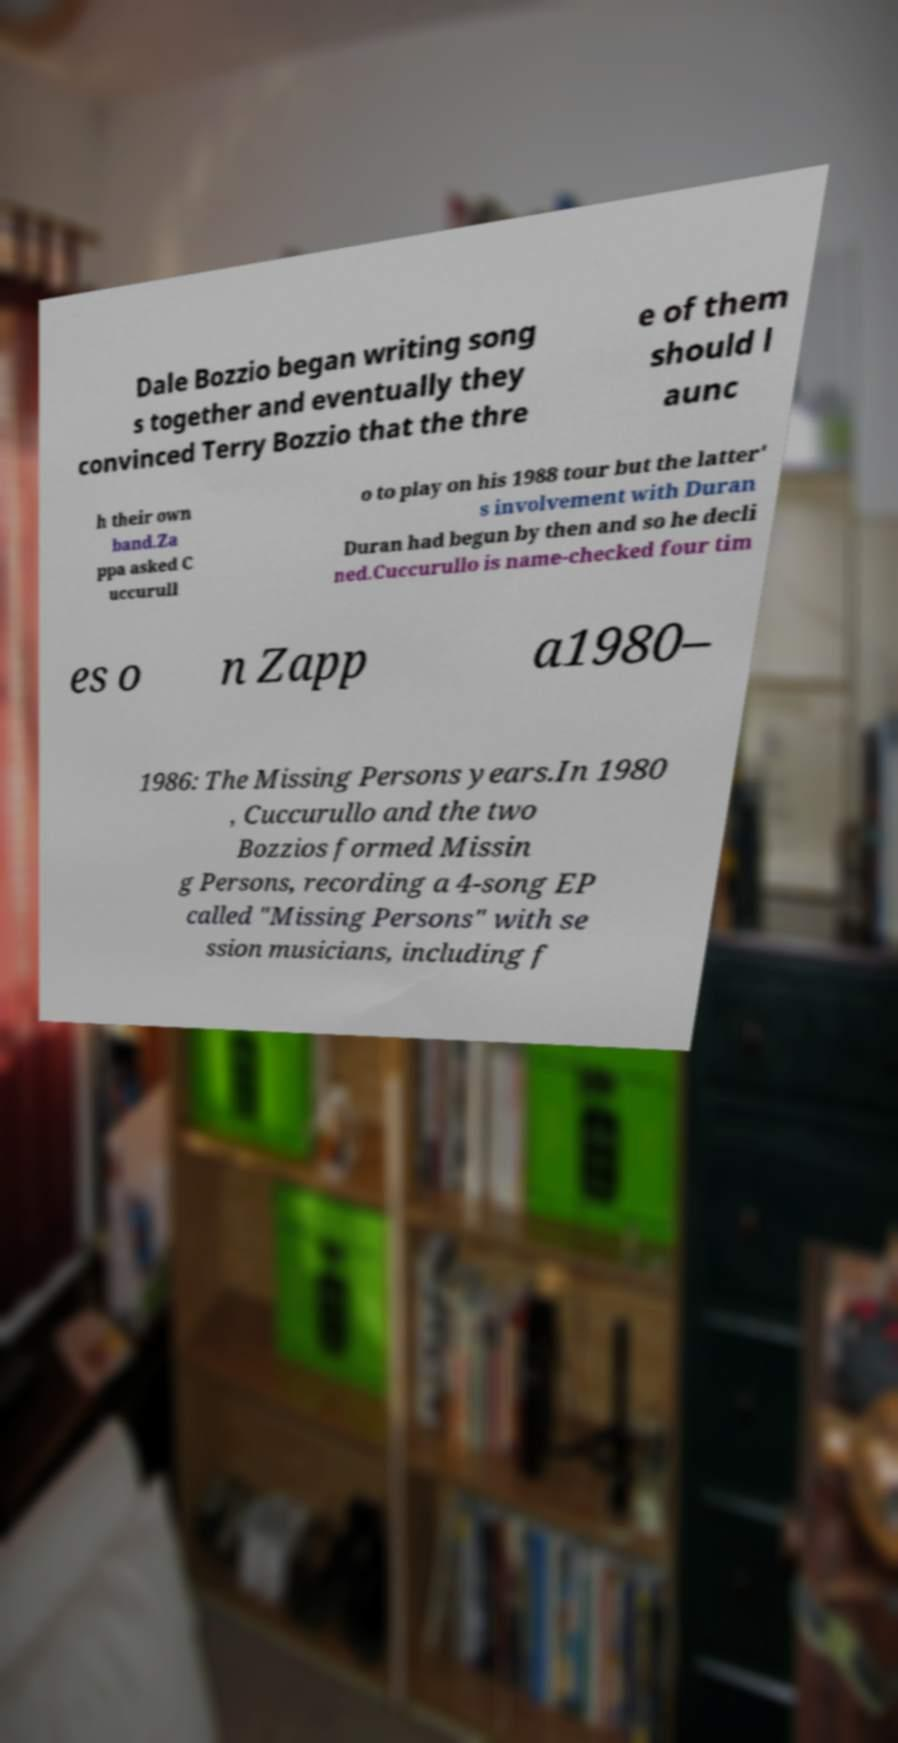Who are the key people mentioned in this text, and what are their significant contributions to the music industry? The key people mentioned are Dale Bozzio, Terry Bozzio, and Warren Cuccurullo. Dale and Terry Bozzio co-founded the new wave band Missing Persons, which became famous in the 1980s. Warren Cuccurullo was also a part of Missing Persons and later joined Duran Duran, contributing significantly to their success. 